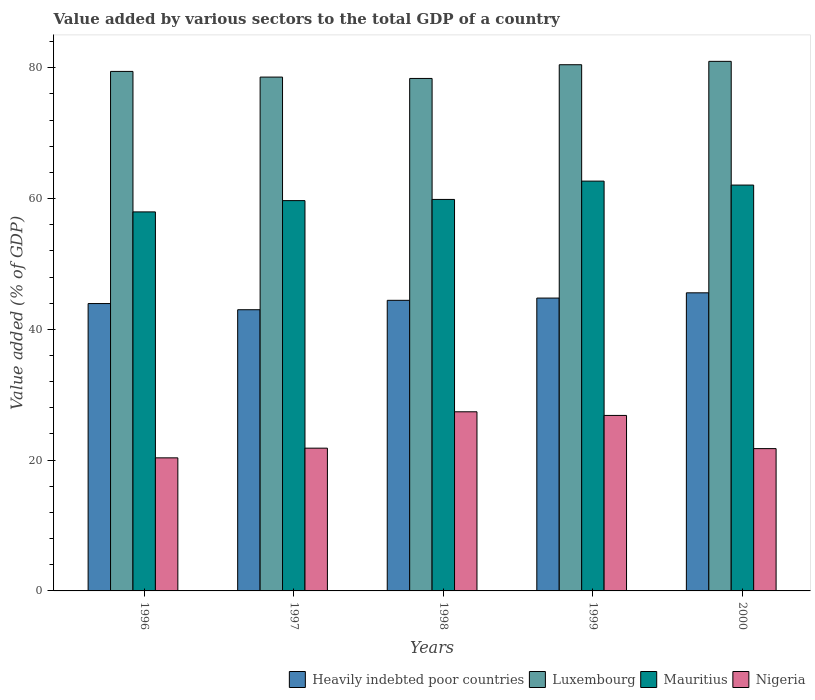Are the number of bars per tick equal to the number of legend labels?
Your answer should be very brief. Yes. Are the number of bars on each tick of the X-axis equal?
Make the answer very short. Yes. How many bars are there on the 1st tick from the left?
Keep it short and to the point. 4. How many bars are there on the 5th tick from the right?
Keep it short and to the point. 4. What is the label of the 5th group of bars from the left?
Offer a terse response. 2000. In how many cases, is the number of bars for a given year not equal to the number of legend labels?
Provide a short and direct response. 0. What is the value added by various sectors to the total GDP in Nigeria in 1996?
Your answer should be compact. 20.35. Across all years, what is the maximum value added by various sectors to the total GDP in Nigeria?
Provide a succinct answer. 27.39. Across all years, what is the minimum value added by various sectors to the total GDP in Nigeria?
Provide a succinct answer. 20.35. In which year was the value added by various sectors to the total GDP in Mauritius minimum?
Provide a succinct answer. 1996. What is the total value added by various sectors to the total GDP in Mauritius in the graph?
Keep it short and to the point. 302.24. What is the difference between the value added by various sectors to the total GDP in Heavily indebted poor countries in 1998 and that in 2000?
Your response must be concise. -1.15. What is the difference between the value added by various sectors to the total GDP in Heavily indebted poor countries in 2000 and the value added by various sectors to the total GDP in Mauritius in 1996?
Keep it short and to the point. -12.38. What is the average value added by various sectors to the total GDP in Mauritius per year?
Provide a succinct answer. 60.45. In the year 1996, what is the difference between the value added by various sectors to the total GDP in Nigeria and value added by various sectors to the total GDP in Luxembourg?
Keep it short and to the point. -59.09. In how many years, is the value added by various sectors to the total GDP in Luxembourg greater than 44 %?
Make the answer very short. 5. What is the ratio of the value added by various sectors to the total GDP in Luxembourg in 1998 to that in 1999?
Your answer should be compact. 0.97. What is the difference between the highest and the second highest value added by various sectors to the total GDP in Luxembourg?
Offer a very short reply. 0.52. What is the difference between the highest and the lowest value added by various sectors to the total GDP in Nigeria?
Provide a short and direct response. 7.04. Is the sum of the value added by various sectors to the total GDP in Luxembourg in 1996 and 1999 greater than the maximum value added by various sectors to the total GDP in Mauritius across all years?
Give a very brief answer. Yes. What does the 1st bar from the left in 1998 represents?
Your answer should be very brief. Heavily indebted poor countries. What does the 2nd bar from the right in 2000 represents?
Offer a terse response. Mauritius. Are all the bars in the graph horizontal?
Your answer should be compact. No. What is the difference between two consecutive major ticks on the Y-axis?
Offer a very short reply. 20. Does the graph contain any zero values?
Offer a terse response. No. Does the graph contain grids?
Your answer should be compact. No. Where does the legend appear in the graph?
Provide a succinct answer. Bottom right. How many legend labels are there?
Give a very brief answer. 4. How are the legend labels stacked?
Provide a short and direct response. Horizontal. What is the title of the graph?
Your answer should be very brief. Value added by various sectors to the total GDP of a country. Does "Montenegro" appear as one of the legend labels in the graph?
Offer a very short reply. No. What is the label or title of the Y-axis?
Give a very brief answer. Value added (% of GDP). What is the Value added (% of GDP) of Heavily indebted poor countries in 1996?
Your answer should be compact. 43.94. What is the Value added (% of GDP) of Luxembourg in 1996?
Your response must be concise. 79.44. What is the Value added (% of GDP) in Mauritius in 1996?
Your response must be concise. 57.96. What is the Value added (% of GDP) in Nigeria in 1996?
Your answer should be very brief. 20.35. What is the Value added (% of GDP) in Heavily indebted poor countries in 1997?
Provide a short and direct response. 43. What is the Value added (% of GDP) of Luxembourg in 1997?
Provide a short and direct response. 78.58. What is the Value added (% of GDP) in Mauritius in 1997?
Offer a very short reply. 59.69. What is the Value added (% of GDP) in Nigeria in 1997?
Offer a very short reply. 21.83. What is the Value added (% of GDP) in Heavily indebted poor countries in 1998?
Your response must be concise. 44.44. What is the Value added (% of GDP) in Luxembourg in 1998?
Your answer should be very brief. 78.37. What is the Value added (% of GDP) in Mauritius in 1998?
Provide a short and direct response. 59.87. What is the Value added (% of GDP) of Nigeria in 1998?
Give a very brief answer. 27.39. What is the Value added (% of GDP) of Heavily indebted poor countries in 1999?
Your answer should be compact. 44.78. What is the Value added (% of GDP) of Luxembourg in 1999?
Your answer should be very brief. 80.47. What is the Value added (% of GDP) in Mauritius in 1999?
Give a very brief answer. 62.67. What is the Value added (% of GDP) of Nigeria in 1999?
Your answer should be very brief. 26.84. What is the Value added (% of GDP) in Heavily indebted poor countries in 2000?
Offer a terse response. 45.59. What is the Value added (% of GDP) of Luxembourg in 2000?
Provide a succinct answer. 80.98. What is the Value added (% of GDP) in Mauritius in 2000?
Offer a very short reply. 62.06. What is the Value added (% of GDP) of Nigeria in 2000?
Your answer should be compact. 21.76. Across all years, what is the maximum Value added (% of GDP) of Heavily indebted poor countries?
Your answer should be compact. 45.59. Across all years, what is the maximum Value added (% of GDP) of Luxembourg?
Give a very brief answer. 80.98. Across all years, what is the maximum Value added (% of GDP) of Mauritius?
Your answer should be very brief. 62.67. Across all years, what is the maximum Value added (% of GDP) of Nigeria?
Provide a short and direct response. 27.39. Across all years, what is the minimum Value added (% of GDP) of Heavily indebted poor countries?
Provide a succinct answer. 43. Across all years, what is the minimum Value added (% of GDP) in Luxembourg?
Your answer should be compact. 78.37. Across all years, what is the minimum Value added (% of GDP) in Mauritius?
Provide a succinct answer. 57.96. Across all years, what is the minimum Value added (% of GDP) in Nigeria?
Ensure brevity in your answer.  20.35. What is the total Value added (% of GDP) in Heavily indebted poor countries in the graph?
Your answer should be compact. 221.75. What is the total Value added (% of GDP) of Luxembourg in the graph?
Ensure brevity in your answer.  397.83. What is the total Value added (% of GDP) in Mauritius in the graph?
Give a very brief answer. 302.24. What is the total Value added (% of GDP) in Nigeria in the graph?
Offer a terse response. 118.17. What is the difference between the Value added (% of GDP) of Heavily indebted poor countries in 1996 and that in 1997?
Your response must be concise. 0.94. What is the difference between the Value added (% of GDP) in Luxembourg in 1996 and that in 1997?
Provide a succinct answer. 0.87. What is the difference between the Value added (% of GDP) of Mauritius in 1996 and that in 1997?
Offer a very short reply. -1.73. What is the difference between the Value added (% of GDP) of Nigeria in 1996 and that in 1997?
Give a very brief answer. -1.48. What is the difference between the Value added (% of GDP) of Heavily indebted poor countries in 1996 and that in 1998?
Provide a succinct answer. -0.5. What is the difference between the Value added (% of GDP) in Luxembourg in 1996 and that in 1998?
Offer a very short reply. 1.08. What is the difference between the Value added (% of GDP) in Mauritius in 1996 and that in 1998?
Provide a succinct answer. -1.91. What is the difference between the Value added (% of GDP) in Nigeria in 1996 and that in 1998?
Give a very brief answer. -7.04. What is the difference between the Value added (% of GDP) in Heavily indebted poor countries in 1996 and that in 1999?
Your answer should be compact. -0.84. What is the difference between the Value added (% of GDP) of Luxembourg in 1996 and that in 1999?
Ensure brevity in your answer.  -1.02. What is the difference between the Value added (% of GDP) in Mauritius in 1996 and that in 1999?
Your answer should be compact. -4.71. What is the difference between the Value added (% of GDP) of Nigeria in 1996 and that in 1999?
Your response must be concise. -6.49. What is the difference between the Value added (% of GDP) of Heavily indebted poor countries in 1996 and that in 2000?
Make the answer very short. -1.64. What is the difference between the Value added (% of GDP) in Luxembourg in 1996 and that in 2000?
Give a very brief answer. -1.54. What is the difference between the Value added (% of GDP) of Mauritius in 1996 and that in 2000?
Your answer should be compact. -4.1. What is the difference between the Value added (% of GDP) in Nigeria in 1996 and that in 2000?
Offer a very short reply. -1.41. What is the difference between the Value added (% of GDP) in Heavily indebted poor countries in 1997 and that in 1998?
Provide a succinct answer. -1.44. What is the difference between the Value added (% of GDP) of Luxembourg in 1997 and that in 1998?
Keep it short and to the point. 0.21. What is the difference between the Value added (% of GDP) in Mauritius in 1997 and that in 1998?
Your answer should be compact. -0.18. What is the difference between the Value added (% of GDP) of Nigeria in 1997 and that in 1998?
Provide a short and direct response. -5.56. What is the difference between the Value added (% of GDP) of Heavily indebted poor countries in 1997 and that in 1999?
Keep it short and to the point. -1.78. What is the difference between the Value added (% of GDP) in Luxembourg in 1997 and that in 1999?
Ensure brevity in your answer.  -1.89. What is the difference between the Value added (% of GDP) in Mauritius in 1997 and that in 1999?
Your answer should be very brief. -2.98. What is the difference between the Value added (% of GDP) of Nigeria in 1997 and that in 1999?
Offer a terse response. -5. What is the difference between the Value added (% of GDP) in Heavily indebted poor countries in 1997 and that in 2000?
Your response must be concise. -2.58. What is the difference between the Value added (% of GDP) of Luxembourg in 1997 and that in 2000?
Your answer should be very brief. -2.41. What is the difference between the Value added (% of GDP) of Mauritius in 1997 and that in 2000?
Ensure brevity in your answer.  -2.38. What is the difference between the Value added (% of GDP) of Nigeria in 1997 and that in 2000?
Your answer should be very brief. 0.07. What is the difference between the Value added (% of GDP) in Heavily indebted poor countries in 1998 and that in 1999?
Your answer should be very brief. -0.34. What is the difference between the Value added (% of GDP) of Luxembourg in 1998 and that in 1999?
Make the answer very short. -2.1. What is the difference between the Value added (% of GDP) in Mauritius in 1998 and that in 1999?
Ensure brevity in your answer.  -2.8. What is the difference between the Value added (% of GDP) of Nigeria in 1998 and that in 1999?
Your answer should be very brief. 0.56. What is the difference between the Value added (% of GDP) of Heavily indebted poor countries in 1998 and that in 2000?
Ensure brevity in your answer.  -1.15. What is the difference between the Value added (% of GDP) of Luxembourg in 1998 and that in 2000?
Keep it short and to the point. -2.61. What is the difference between the Value added (% of GDP) in Mauritius in 1998 and that in 2000?
Your answer should be compact. -2.2. What is the difference between the Value added (% of GDP) in Nigeria in 1998 and that in 2000?
Offer a very short reply. 5.63. What is the difference between the Value added (% of GDP) of Heavily indebted poor countries in 1999 and that in 2000?
Provide a short and direct response. -0.8. What is the difference between the Value added (% of GDP) in Luxembourg in 1999 and that in 2000?
Your answer should be very brief. -0.52. What is the difference between the Value added (% of GDP) of Mauritius in 1999 and that in 2000?
Give a very brief answer. 0.6. What is the difference between the Value added (% of GDP) in Nigeria in 1999 and that in 2000?
Your response must be concise. 5.08. What is the difference between the Value added (% of GDP) in Heavily indebted poor countries in 1996 and the Value added (% of GDP) in Luxembourg in 1997?
Provide a succinct answer. -34.63. What is the difference between the Value added (% of GDP) of Heavily indebted poor countries in 1996 and the Value added (% of GDP) of Mauritius in 1997?
Make the answer very short. -15.74. What is the difference between the Value added (% of GDP) in Heavily indebted poor countries in 1996 and the Value added (% of GDP) in Nigeria in 1997?
Offer a very short reply. 22.11. What is the difference between the Value added (% of GDP) in Luxembourg in 1996 and the Value added (% of GDP) in Mauritius in 1997?
Your answer should be very brief. 19.76. What is the difference between the Value added (% of GDP) of Luxembourg in 1996 and the Value added (% of GDP) of Nigeria in 1997?
Offer a very short reply. 57.61. What is the difference between the Value added (% of GDP) in Mauritius in 1996 and the Value added (% of GDP) in Nigeria in 1997?
Provide a succinct answer. 36.13. What is the difference between the Value added (% of GDP) of Heavily indebted poor countries in 1996 and the Value added (% of GDP) of Luxembourg in 1998?
Offer a terse response. -34.42. What is the difference between the Value added (% of GDP) in Heavily indebted poor countries in 1996 and the Value added (% of GDP) in Mauritius in 1998?
Your answer should be very brief. -15.92. What is the difference between the Value added (% of GDP) of Heavily indebted poor countries in 1996 and the Value added (% of GDP) of Nigeria in 1998?
Make the answer very short. 16.55. What is the difference between the Value added (% of GDP) of Luxembourg in 1996 and the Value added (% of GDP) of Mauritius in 1998?
Keep it short and to the point. 19.58. What is the difference between the Value added (% of GDP) in Luxembourg in 1996 and the Value added (% of GDP) in Nigeria in 1998?
Your answer should be very brief. 52.05. What is the difference between the Value added (% of GDP) of Mauritius in 1996 and the Value added (% of GDP) of Nigeria in 1998?
Offer a very short reply. 30.57. What is the difference between the Value added (% of GDP) of Heavily indebted poor countries in 1996 and the Value added (% of GDP) of Luxembourg in 1999?
Your answer should be very brief. -36.52. What is the difference between the Value added (% of GDP) in Heavily indebted poor countries in 1996 and the Value added (% of GDP) in Mauritius in 1999?
Provide a succinct answer. -18.72. What is the difference between the Value added (% of GDP) of Heavily indebted poor countries in 1996 and the Value added (% of GDP) of Nigeria in 1999?
Give a very brief answer. 17.11. What is the difference between the Value added (% of GDP) of Luxembourg in 1996 and the Value added (% of GDP) of Mauritius in 1999?
Ensure brevity in your answer.  16.78. What is the difference between the Value added (% of GDP) in Luxembourg in 1996 and the Value added (% of GDP) in Nigeria in 1999?
Keep it short and to the point. 52.61. What is the difference between the Value added (% of GDP) in Mauritius in 1996 and the Value added (% of GDP) in Nigeria in 1999?
Keep it short and to the point. 31.13. What is the difference between the Value added (% of GDP) in Heavily indebted poor countries in 1996 and the Value added (% of GDP) in Luxembourg in 2000?
Make the answer very short. -37.04. What is the difference between the Value added (% of GDP) in Heavily indebted poor countries in 1996 and the Value added (% of GDP) in Mauritius in 2000?
Your answer should be very brief. -18.12. What is the difference between the Value added (% of GDP) in Heavily indebted poor countries in 1996 and the Value added (% of GDP) in Nigeria in 2000?
Offer a very short reply. 22.18. What is the difference between the Value added (% of GDP) of Luxembourg in 1996 and the Value added (% of GDP) of Mauritius in 2000?
Offer a terse response. 17.38. What is the difference between the Value added (% of GDP) of Luxembourg in 1996 and the Value added (% of GDP) of Nigeria in 2000?
Your answer should be compact. 57.68. What is the difference between the Value added (% of GDP) of Mauritius in 1996 and the Value added (% of GDP) of Nigeria in 2000?
Keep it short and to the point. 36.2. What is the difference between the Value added (% of GDP) in Heavily indebted poor countries in 1997 and the Value added (% of GDP) in Luxembourg in 1998?
Keep it short and to the point. -35.37. What is the difference between the Value added (% of GDP) in Heavily indebted poor countries in 1997 and the Value added (% of GDP) in Mauritius in 1998?
Ensure brevity in your answer.  -16.87. What is the difference between the Value added (% of GDP) of Heavily indebted poor countries in 1997 and the Value added (% of GDP) of Nigeria in 1998?
Give a very brief answer. 15.61. What is the difference between the Value added (% of GDP) in Luxembourg in 1997 and the Value added (% of GDP) in Mauritius in 1998?
Offer a terse response. 18.71. What is the difference between the Value added (% of GDP) of Luxembourg in 1997 and the Value added (% of GDP) of Nigeria in 1998?
Provide a short and direct response. 51.18. What is the difference between the Value added (% of GDP) in Mauritius in 1997 and the Value added (% of GDP) in Nigeria in 1998?
Provide a short and direct response. 32.29. What is the difference between the Value added (% of GDP) of Heavily indebted poor countries in 1997 and the Value added (% of GDP) of Luxembourg in 1999?
Give a very brief answer. -37.46. What is the difference between the Value added (% of GDP) in Heavily indebted poor countries in 1997 and the Value added (% of GDP) in Mauritius in 1999?
Your response must be concise. -19.67. What is the difference between the Value added (% of GDP) of Heavily indebted poor countries in 1997 and the Value added (% of GDP) of Nigeria in 1999?
Your answer should be compact. 16.17. What is the difference between the Value added (% of GDP) in Luxembourg in 1997 and the Value added (% of GDP) in Mauritius in 1999?
Give a very brief answer. 15.91. What is the difference between the Value added (% of GDP) of Luxembourg in 1997 and the Value added (% of GDP) of Nigeria in 1999?
Make the answer very short. 51.74. What is the difference between the Value added (% of GDP) of Mauritius in 1997 and the Value added (% of GDP) of Nigeria in 1999?
Keep it short and to the point. 32.85. What is the difference between the Value added (% of GDP) of Heavily indebted poor countries in 1997 and the Value added (% of GDP) of Luxembourg in 2000?
Offer a terse response. -37.98. What is the difference between the Value added (% of GDP) of Heavily indebted poor countries in 1997 and the Value added (% of GDP) of Mauritius in 2000?
Give a very brief answer. -19.06. What is the difference between the Value added (% of GDP) of Heavily indebted poor countries in 1997 and the Value added (% of GDP) of Nigeria in 2000?
Provide a succinct answer. 21.24. What is the difference between the Value added (% of GDP) of Luxembourg in 1997 and the Value added (% of GDP) of Mauritius in 2000?
Keep it short and to the point. 16.51. What is the difference between the Value added (% of GDP) of Luxembourg in 1997 and the Value added (% of GDP) of Nigeria in 2000?
Your answer should be very brief. 56.81. What is the difference between the Value added (% of GDP) of Mauritius in 1997 and the Value added (% of GDP) of Nigeria in 2000?
Keep it short and to the point. 37.93. What is the difference between the Value added (% of GDP) of Heavily indebted poor countries in 1998 and the Value added (% of GDP) of Luxembourg in 1999?
Make the answer very short. -36.03. What is the difference between the Value added (% of GDP) of Heavily indebted poor countries in 1998 and the Value added (% of GDP) of Mauritius in 1999?
Your response must be concise. -18.23. What is the difference between the Value added (% of GDP) of Heavily indebted poor countries in 1998 and the Value added (% of GDP) of Nigeria in 1999?
Give a very brief answer. 17.6. What is the difference between the Value added (% of GDP) of Luxembourg in 1998 and the Value added (% of GDP) of Mauritius in 1999?
Provide a succinct answer. 15.7. What is the difference between the Value added (% of GDP) of Luxembourg in 1998 and the Value added (% of GDP) of Nigeria in 1999?
Your answer should be very brief. 51.53. What is the difference between the Value added (% of GDP) of Mauritius in 1998 and the Value added (% of GDP) of Nigeria in 1999?
Make the answer very short. 33.03. What is the difference between the Value added (% of GDP) of Heavily indebted poor countries in 1998 and the Value added (% of GDP) of Luxembourg in 2000?
Offer a very short reply. -36.54. What is the difference between the Value added (% of GDP) of Heavily indebted poor countries in 1998 and the Value added (% of GDP) of Mauritius in 2000?
Give a very brief answer. -17.62. What is the difference between the Value added (% of GDP) in Heavily indebted poor countries in 1998 and the Value added (% of GDP) in Nigeria in 2000?
Your response must be concise. 22.68. What is the difference between the Value added (% of GDP) in Luxembourg in 1998 and the Value added (% of GDP) in Mauritius in 2000?
Keep it short and to the point. 16.3. What is the difference between the Value added (% of GDP) in Luxembourg in 1998 and the Value added (% of GDP) in Nigeria in 2000?
Your answer should be very brief. 56.61. What is the difference between the Value added (% of GDP) in Mauritius in 1998 and the Value added (% of GDP) in Nigeria in 2000?
Your answer should be compact. 38.11. What is the difference between the Value added (% of GDP) in Heavily indebted poor countries in 1999 and the Value added (% of GDP) in Luxembourg in 2000?
Give a very brief answer. -36.2. What is the difference between the Value added (% of GDP) of Heavily indebted poor countries in 1999 and the Value added (% of GDP) of Mauritius in 2000?
Your answer should be very brief. -17.28. What is the difference between the Value added (% of GDP) in Heavily indebted poor countries in 1999 and the Value added (% of GDP) in Nigeria in 2000?
Your answer should be very brief. 23.02. What is the difference between the Value added (% of GDP) in Luxembourg in 1999 and the Value added (% of GDP) in Mauritius in 2000?
Provide a short and direct response. 18.4. What is the difference between the Value added (% of GDP) in Luxembourg in 1999 and the Value added (% of GDP) in Nigeria in 2000?
Give a very brief answer. 58.7. What is the difference between the Value added (% of GDP) of Mauritius in 1999 and the Value added (% of GDP) of Nigeria in 2000?
Your response must be concise. 40.91. What is the average Value added (% of GDP) in Heavily indebted poor countries per year?
Your answer should be very brief. 44.35. What is the average Value added (% of GDP) in Luxembourg per year?
Your answer should be compact. 79.57. What is the average Value added (% of GDP) in Mauritius per year?
Your answer should be compact. 60.45. What is the average Value added (% of GDP) in Nigeria per year?
Your answer should be very brief. 23.63. In the year 1996, what is the difference between the Value added (% of GDP) of Heavily indebted poor countries and Value added (% of GDP) of Luxembourg?
Your answer should be very brief. -35.5. In the year 1996, what is the difference between the Value added (% of GDP) in Heavily indebted poor countries and Value added (% of GDP) in Mauritius?
Offer a very short reply. -14.02. In the year 1996, what is the difference between the Value added (% of GDP) in Heavily indebted poor countries and Value added (% of GDP) in Nigeria?
Your response must be concise. 23.59. In the year 1996, what is the difference between the Value added (% of GDP) in Luxembourg and Value added (% of GDP) in Mauritius?
Your response must be concise. 21.48. In the year 1996, what is the difference between the Value added (% of GDP) of Luxembourg and Value added (% of GDP) of Nigeria?
Keep it short and to the point. 59.09. In the year 1996, what is the difference between the Value added (% of GDP) in Mauritius and Value added (% of GDP) in Nigeria?
Offer a very short reply. 37.61. In the year 1997, what is the difference between the Value added (% of GDP) in Heavily indebted poor countries and Value added (% of GDP) in Luxembourg?
Keep it short and to the point. -35.57. In the year 1997, what is the difference between the Value added (% of GDP) in Heavily indebted poor countries and Value added (% of GDP) in Mauritius?
Provide a succinct answer. -16.68. In the year 1997, what is the difference between the Value added (% of GDP) of Heavily indebted poor countries and Value added (% of GDP) of Nigeria?
Offer a very short reply. 21.17. In the year 1997, what is the difference between the Value added (% of GDP) of Luxembourg and Value added (% of GDP) of Mauritius?
Provide a succinct answer. 18.89. In the year 1997, what is the difference between the Value added (% of GDP) of Luxembourg and Value added (% of GDP) of Nigeria?
Give a very brief answer. 56.74. In the year 1997, what is the difference between the Value added (% of GDP) in Mauritius and Value added (% of GDP) in Nigeria?
Keep it short and to the point. 37.85. In the year 1998, what is the difference between the Value added (% of GDP) in Heavily indebted poor countries and Value added (% of GDP) in Luxembourg?
Your answer should be compact. -33.93. In the year 1998, what is the difference between the Value added (% of GDP) in Heavily indebted poor countries and Value added (% of GDP) in Mauritius?
Provide a succinct answer. -15.43. In the year 1998, what is the difference between the Value added (% of GDP) of Heavily indebted poor countries and Value added (% of GDP) of Nigeria?
Your answer should be compact. 17.05. In the year 1998, what is the difference between the Value added (% of GDP) in Luxembourg and Value added (% of GDP) in Mauritius?
Your answer should be compact. 18.5. In the year 1998, what is the difference between the Value added (% of GDP) of Luxembourg and Value added (% of GDP) of Nigeria?
Keep it short and to the point. 50.97. In the year 1998, what is the difference between the Value added (% of GDP) in Mauritius and Value added (% of GDP) in Nigeria?
Provide a succinct answer. 32.47. In the year 1999, what is the difference between the Value added (% of GDP) in Heavily indebted poor countries and Value added (% of GDP) in Luxembourg?
Your answer should be compact. -35.68. In the year 1999, what is the difference between the Value added (% of GDP) of Heavily indebted poor countries and Value added (% of GDP) of Mauritius?
Your answer should be compact. -17.88. In the year 1999, what is the difference between the Value added (% of GDP) in Heavily indebted poor countries and Value added (% of GDP) in Nigeria?
Your answer should be compact. 17.95. In the year 1999, what is the difference between the Value added (% of GDP) in Luxembourg and Value added (% of GDP) in Mauritius?
Ensure brevity in your answer.  17.8. In the year 1999, what is the difference between the Value added (% of GDP) in Luxembourg and Value added (% of GDP) in Nigeria?
Offer a terse response. 53.63. In the year 1999, what is the difference between the Value added (% of GDP) in Mauritius and Value added (% of GDP) in Nigeria?
Provide a short and direct response. 35.83. In the year 2000, what is the difference between the Value added (% of GDP) in Heavily indebted poor countries and Value added (% of GDP) in Luxembourg?
Keep it short and to the point. -35.4. In the year 2000, what is the difference between the Value added (% of GDP) in Heavily indebted poor countries and Value added (% of GDP) in Mauritius?
Give a very brief answer. -16.48. In the year 2000, what is the difference between the Value added (% of GDP) in Heavily indebted poor countries and Value added (% of GDP) in Nigeria?
Your answer should be compact. 23.82. In the year 2000, what is the difference between the Value added (% of GDP) in Luxembourg and Value added (% of GDP) in Mauritius?
Provide a succinct answer. 18.92. In the year 2000, what is the difference between the Value added (% of GDP) of Luxembourg and Value added (% of GDP) of Nigeria?
Offer a terse response. 59.22. In the year 2000, what is the difference between the Value added (% of GDP) of Mauritius and Value added (% of GDP) of Nigeria?
Your answer should be very brief. 40.3. What is the ratio of the Value added (% of GDP) of Heavily indebted poor countries in 1996 to that in 1997?
Offer a very short reply. 1.02. What is the ratio of the Value added (% of GDP) of Luxembourg in 1996 to that in 1997?
Make the answer very short. 1.01. What is the ratio of the Value added (% of GDP) of Mauritius in 1996 to that in 1997?
Your answer should be very brief. 0.97. What is the ratio of the Value added (% of GDP) in Nigeria in 1996 to that in 1997?
Your answer should be compact. 0.93. What is the ratio of the Value added (% of GDP) of Heavily indebted poor countries in 1996 to that in 1998?
Your answer should be compact. 0.99. What is the ratio of the Value added (% of GDP) in Luxembourg in 1996 to that in 1998?
Offer a terse response. 1.01. What is the ratio of the Value added (% of GDP) of Mauritius in 1996 to that in 1998?
Offer a very short reply. 0.97. What is the ratio of the Value added (% of GDP) in Nigeria in 1996 to that in 1998?
Offer a terse response. 0.74. What is the ratio of the Value added (% of GDP) of Heavily indebted poor countries in 1996 to that in 1999?
Offer a very short reply. 0.98. What is the ratio of the Value added (% of GDP) in Luxembourg in 1996 to that in 1999?
Provide a short and direct response. 0.99. What is the ratio of the Value added (% of GDP) in Mauritius in 1996 to that in 1999?
Keep it short and to the point. 0.92. What is the ratio of the Value added (% of GDP) in Nigeria in 1996 to that in 1999?
Your answer should be very brief. 0.76. What is the ratio of the Value added (% of GDP) in Luxembourg in 1996 to that in 2000?
Give a very brief answer. 0.98. What is the ratio of the Value added (% of GDP) of Mauritius in 1996 to that in 2000?
Provide a short and direct response. 0.93. What is the ratio of the Value added (% of GDP) of Nigeria in 1996 to that in 2000?
Ensure brevity in your answer.  0.94. What is the ratio of the Value added (% of GDP) of Heavily indebted poor countries in 1997 to that in 1998?
Provide a succinct answer. 0.97. What is the ratio of the Value added (% of GDP) of Luxembourg in 1997 to that in 1998?
Your answer should be very brief. 1. What is the ratio of the Value added (% of GDP) in Nigeria in 1997 to that in 1998?
Provide a succinct answer. 0.8. What is the ratio of the Value added (% of GDP) of Heavily indebted poor countries in 1997 to that in 1999?
Offer a very short reply. 0.96. What is the ratio of the Value added (% of GDP) in Luxembourg in 1997 to that in 1999?
Offer a terse response. 0.98. What is the ratio of the Value added (% of GDP) of Mauritius in 1997 to that in 1999?
Provide a short and direct response. 0.95. What is the ratio of the Value added (% of GDP) in Nigeria in 1997 to that in 1999?
Offer a terse response. 0.81. What is the ratio of the Value added (% of GDP) in Heavily indebted poor countries in 1997 to that in 2000?
Provide a short and direct response. 0.94. What is the ratio of the Value added (% of GDP) of Luxembourg in 1997 to that in 2000?
Offer a terse response. 0.97. What is the ratio of the Value added (% of GDP) in Mauritius in 1997 to that in 2000?
Provide a succinct answer. 0.96. What is the ratio of the Value added (% of GDP) in Nigeria in 1997 to that in 2000?
Provide a short and direct response. 1. What is the ratio of the Value added (% of GDP) in Luxembourg in 1998 to that in 1999?
Keep it short and to the point. 0.97. What is the ratio of the Value added (% of GDP) in Mauritius in 1998 to that in 1999?
Give a very brief answer. 0.96. What is the ratio of the Value added (% of GDP) in Nigeria in 1998 to that in 1999?
Your answer should be compact. 1.02. What is the ratio of the Value added (% of GDP) of Heavily indebted poor countries in 1998 to that in 2000?
Offer a very short reply. 0.97. What is the ratio of the Value added (% of GDP) in Luxembourg in 1998 to that in 2000?
Your response must be concise. 0.97. What is the ratio of the Value added (% of GDP) of Mauritius in 1998 to that in 2000?
Give a very brief answer. 0.96. What is the ratio of the Value added (% of GDP) in Nigeria in 1998 to that in 2000?
Offer a very short reply. 1.26. What is the ratio of the Value added (% of GDP) in Heavily indebted poor countries in 1999 to that in 2000?
Your response must be concise. 0.98. What is the ratio of the Value added (% of GDP) of Mauritius in 1999 to that in 2000?
Provide a succinct answer. 1.01. What is the ratio of the Value added (% of GDP) of Nigeria in 1999 to that in 2000?
Keep it short and to the point. 1.23. What is the difference between the highest and the second highest Value added (% of GDP) in Heavily indebted poor countries?
Give a very brief answer. 0.8. What is the difference between the highest and the second highest Value added (% of GDP) in Luxembourg?
Your answer should be compact. 0.52. What is the difference between the highest and the second highest Value added (% of GDP) of Mauritius?
Your answer should be very brief. 0.6. What is the difference between the highest and the second highest Value added (% of GDP) in Nigeria?
Keep it short and to the point. 0.56. What is the difference between the highest and the lowest Value added (% of GDP) of Heavily indebted poor countries?
Make the answer very short. 2.58. What is the difference between the highest and the lowest Value added (% of GDP) of Luxembourg?
Keep it short and to the point. 2.61. What is the difference between the highest and the lowest Value added (% of GDP) in Mauritius?
Keep it short and to the point. 4.71. What is the difference between the highest and the lowest Value added (% of GDP) in Nigeria?
Give a very brief answer. 7.04. 